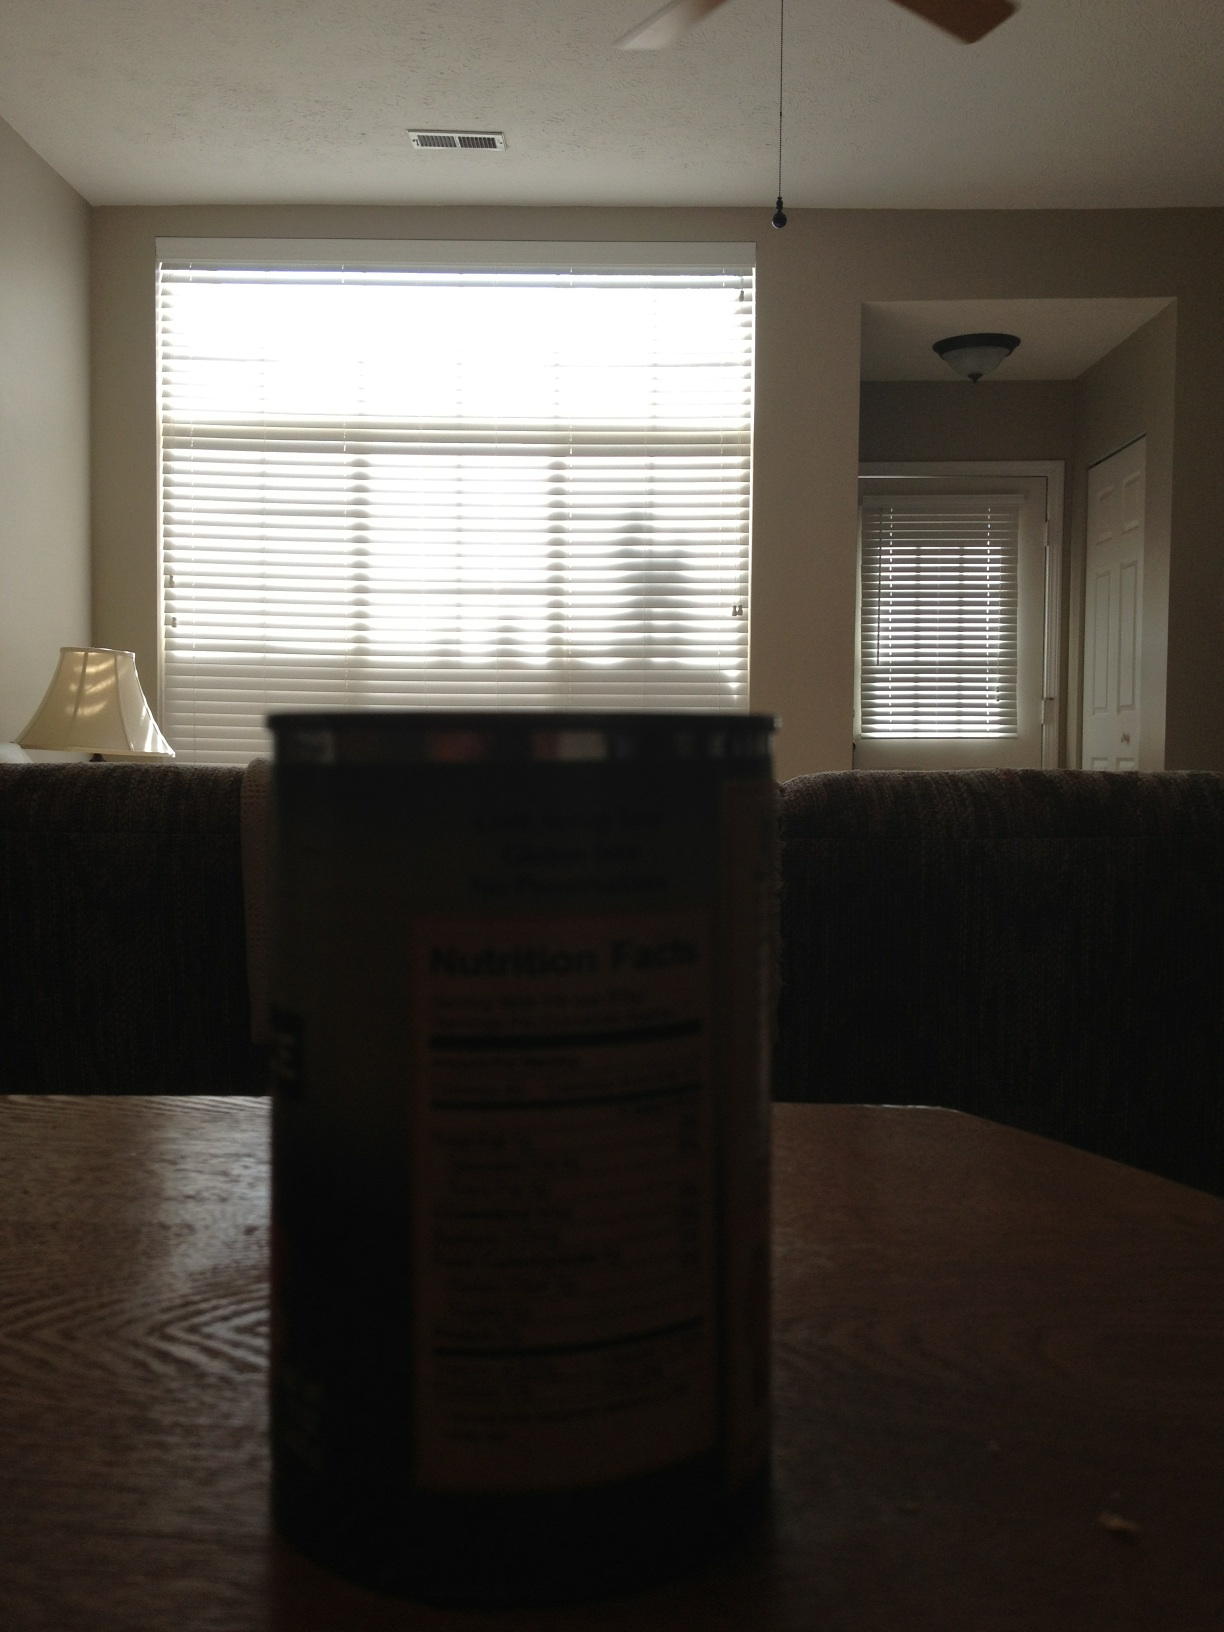Imagine a fantastical scenario where this room transforms dramatically every hour. What might it turn into at midnight? At midnight, the room transforms into an enchanted garden, flowers blooming around the walls, vines creeping up the furniture. Twinkling fairy lights illuminate the space, and a soft, magical glow emanates from the can, now appearing to be an ancient relic with mysterious powers. 